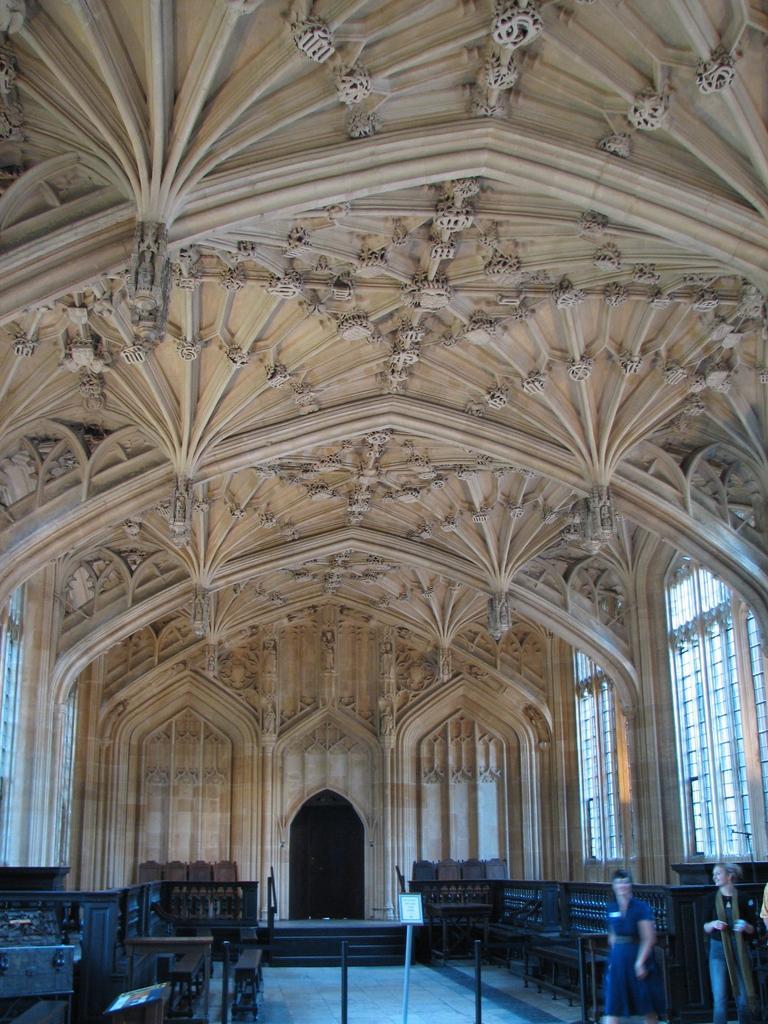In one or two sentences, can you explain what this image depicts? This image consists of a building. It is clicked inside. It looks like a church. To the left and right, there are benches. At the bottom, there is a floor. 